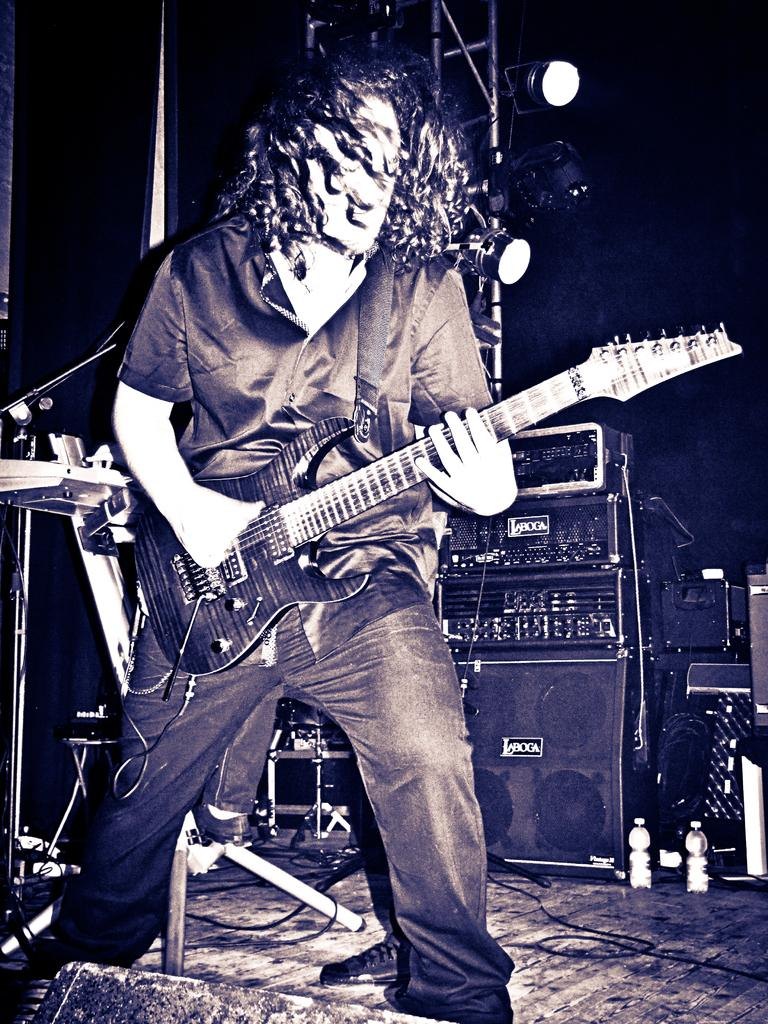What is the main subject of the image? There is a person in the image. What is the person holding in the image? The person is holding a guitar. Can you see a yak in the image? No, there is no yak present in the image. What type of food is the person holding in the image? The person is not holding any type of food in the image; they are holding a guitar. 